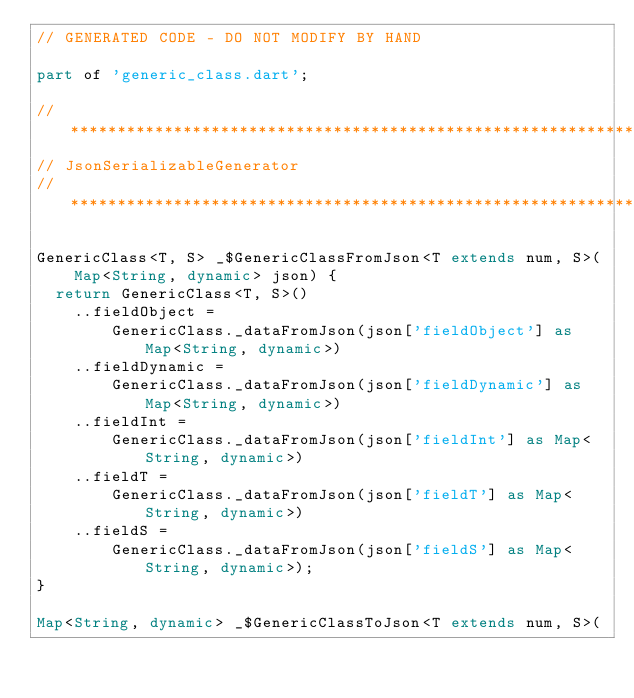<code> <loc_0><loc_0><loc_500><loc_500><_Dart_>// GENERATED CODE - DO NOT MODIFY BY HAND

part of 'generic_class.dart';

// **************************************************************************
// JsonSerializableGenerator
// **************************************************************************

GenericClass<T, S> _$GenericClassFromJson<T extends num, S>(
    Map<String, dynamic> json) {
  return GenericClass<T, S>()
    ..fieldObject =
        GenericClass._dataFromJson(json['fieldObject'] as Map<String, dynamic>)
    ..fieldDynamic =
        GenericClass._dataFromJson(json['fieldDynamic'] as Map<String, dynamic>)
    ..fieldInt =
        GenericClass._dataFromJson(json['fieldInt'] as Map<String, dynamic>)
    ..fieldT =
        GenericClass._dataFromJson(json['fieldT'] as Map<String, dynamic>)
    ..fieldS =
        GenericClass._dataFromJson(json['fieldS'] as Map<String, dynamic>);
}

Map<String, dynamic> _$GenericClassToJson<T extends num, S>(</code> 